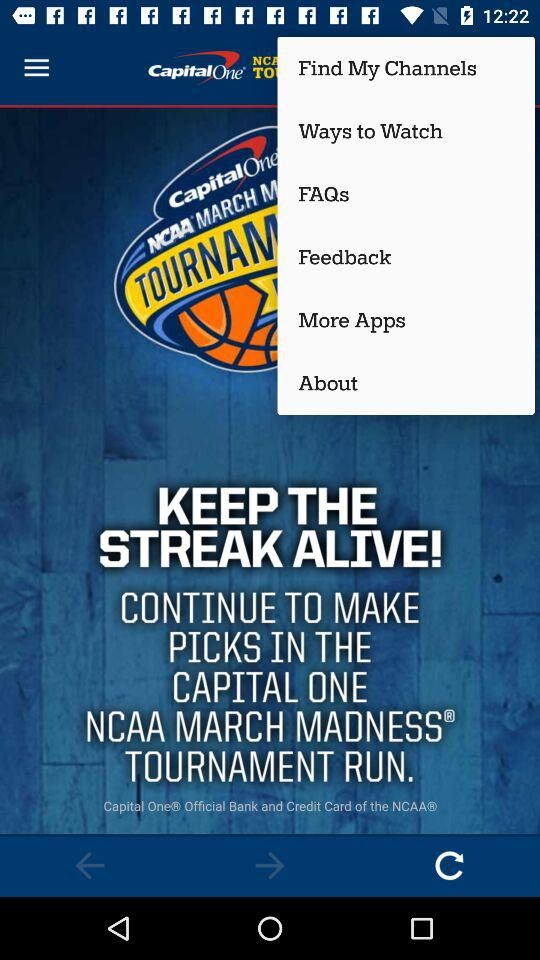What is the application name? The application name is "CapitalOne". 